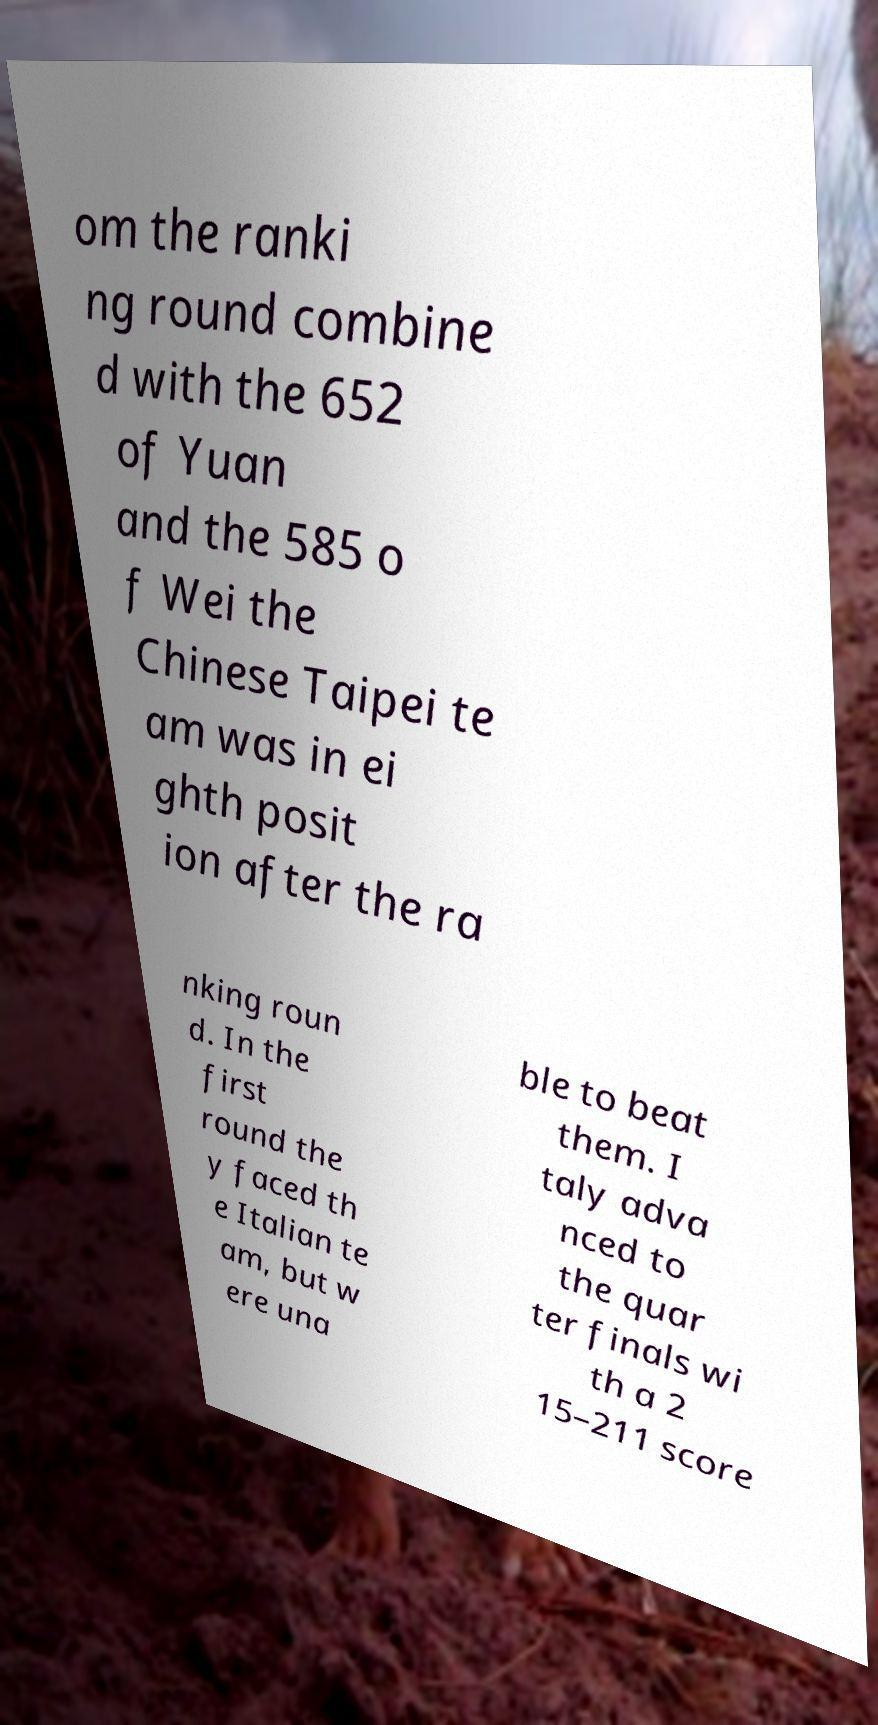Can you read and provide the text displayed in the image?This photo seems to have some interesting text. Can you extract and type it out for me? om the ranki ng round combine d with the 652 of Yuan and the 585 o f Wei the Chinese Taipei te am was in ei ghth posit ion after the ra nking roun d. In the first round the y faced th e Italian te am, but w ere una ble to beat them. I taly adva nced to the quar ter finals wi th a 2 15–211 score 